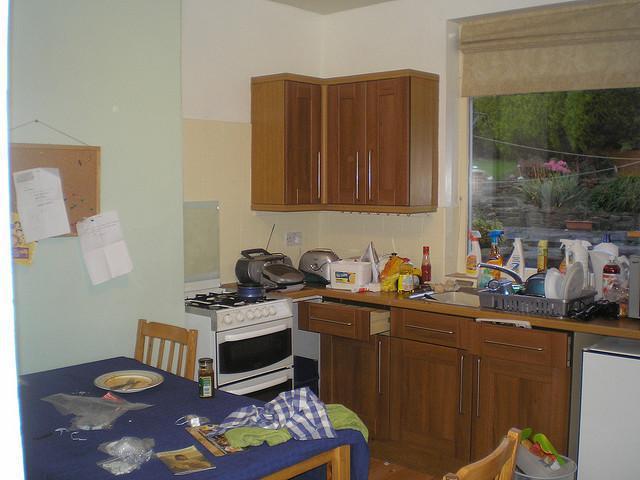What is the object with the metal rod on it?
Select the accurate response from the four choices given to answer the question.
Options: Radio, coffee maker, tv, microwave. Radio. 